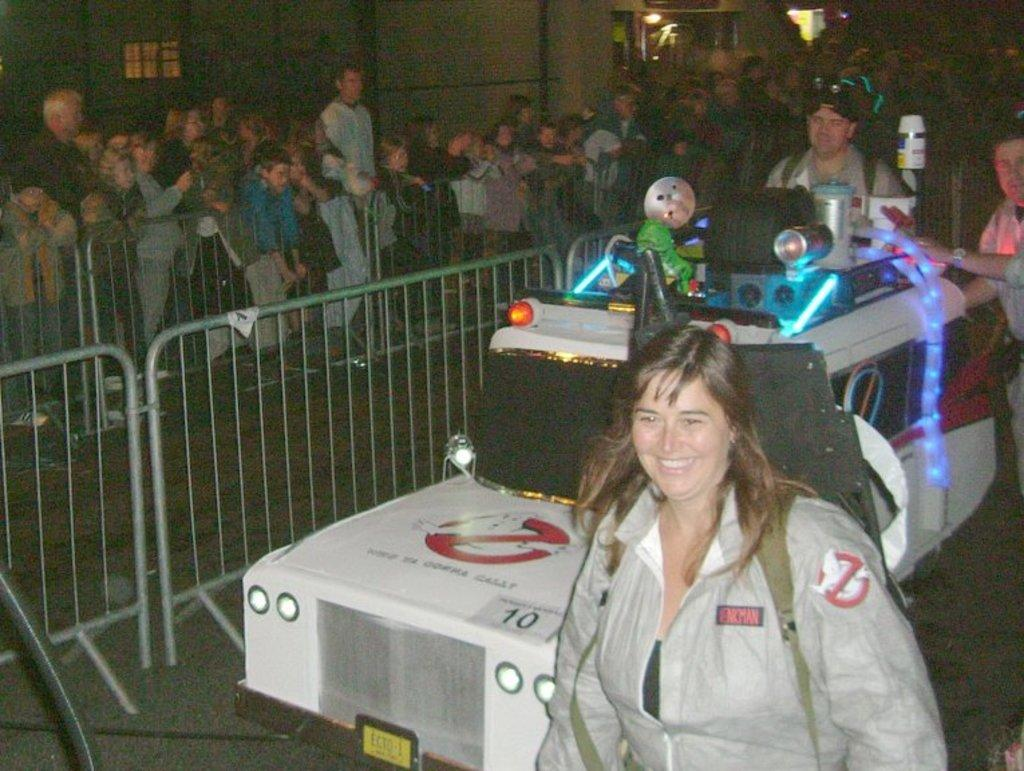What is the main subject of the image? There is a vehicle in the image. Are there any people present in the image? Yes, there are people in the image. What type of structure can be seen in the image? There is a fence in the image. What else can be seen in the image besides the vehicle, people, and fence? There are lights in the image. What type of drug is being administered to the people in the image? There is no indication of any drug being administered or present in the image. 